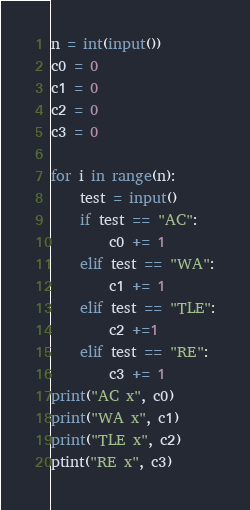<code> <loc_0><loc_0><loc_500><loc_500><_Python_>n = int(input())
c0 = 0
c1 = 0
c2 = 0
c3 = 0

for i in range(n):
    test = input()
    if test == "AC":
        c0 += 1
    elif test == "WA":
        c1 += 1
    elif test == "TLE":
        c2 +=1
    elif test == "RE":
        c3 += 1
print("AC x", c0)
print("WA x", c1)
print("TLE x", c2)
ptint("RE x", c3)</code> 